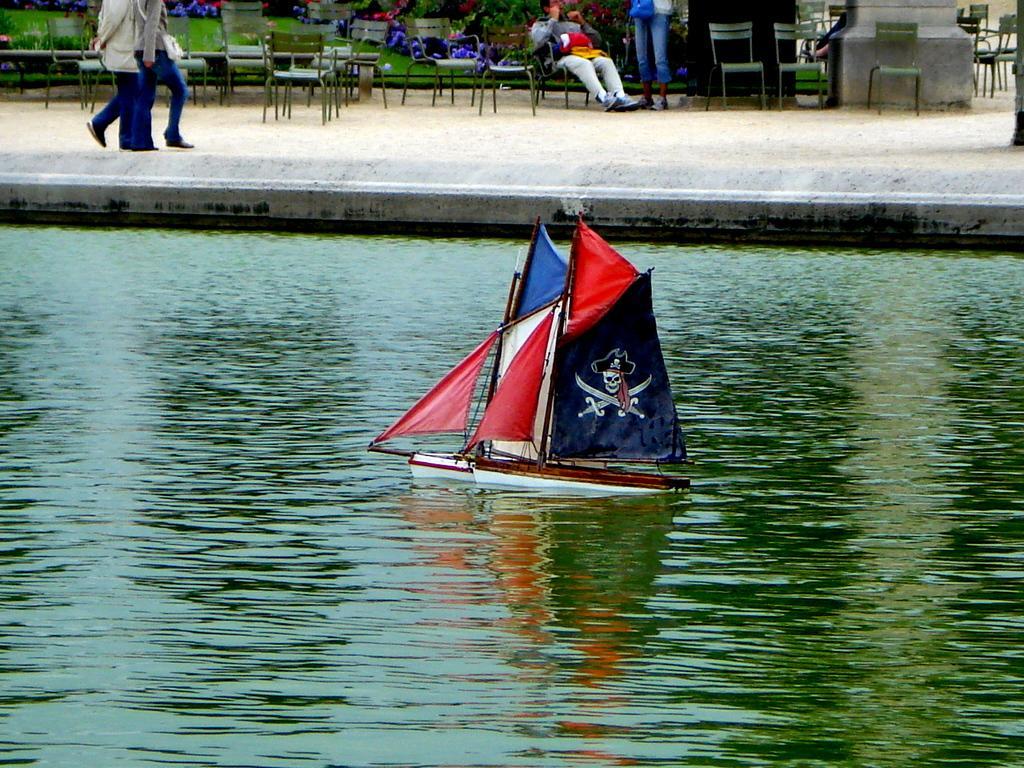Could you give a brief overview of what you see in this image? In this image there is water and we can see boats on the water. In the background there are people and we can see person sitting and there are chairs. 